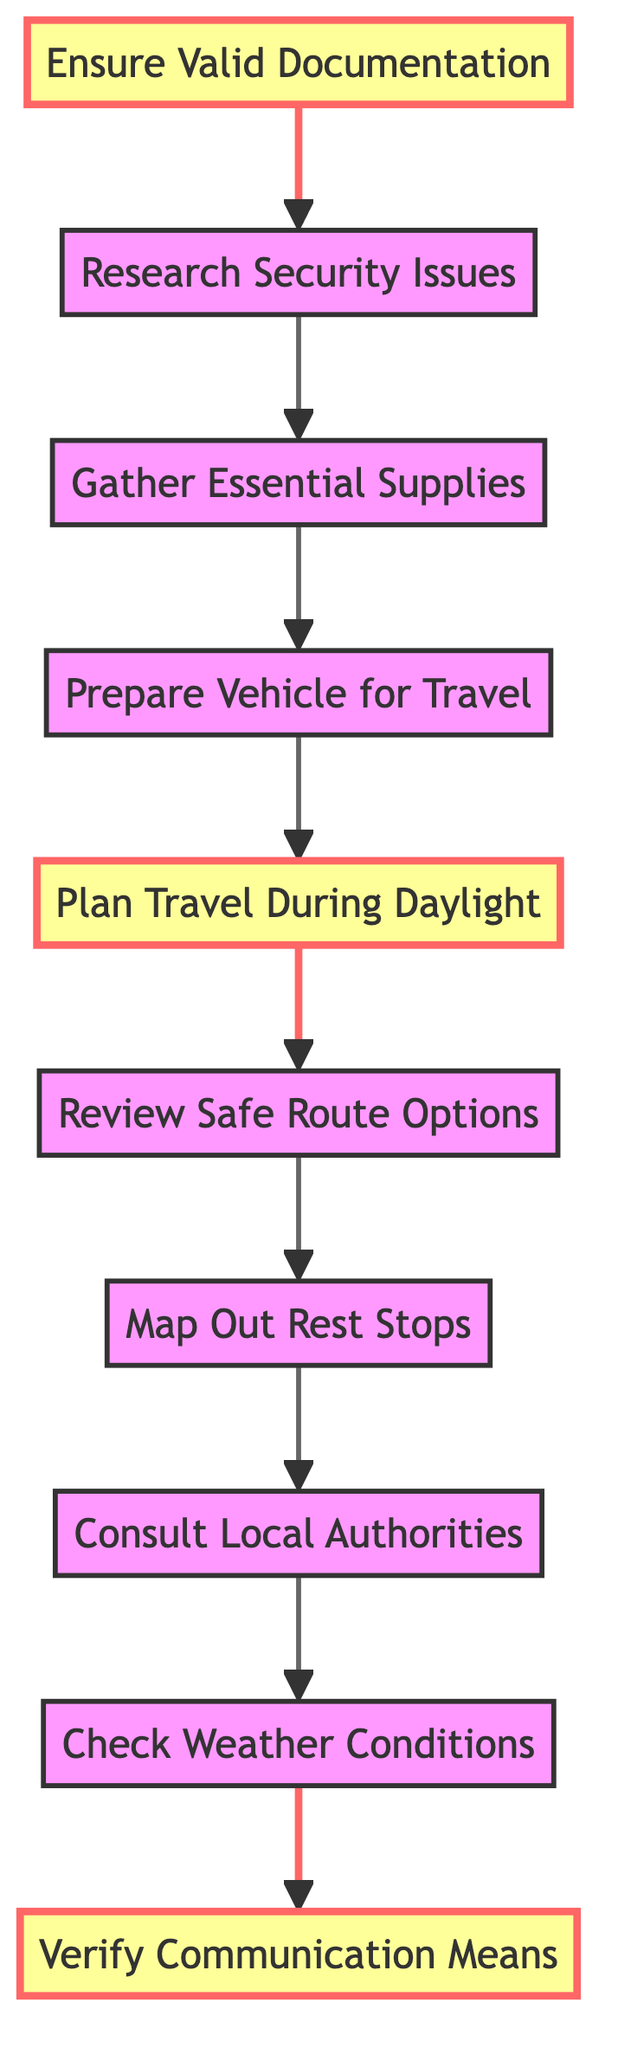What is the starting point of the flowchart? The flowchart starts at the node "Ensure Valid Documentation." This is the first action that needs to be taken, as indicated by the arrow pointing to the next node.
Answer: Ensure Valid Documentation How many nodes are present in the flowchart? The flowchart contains 10 nodes in total, each representing a different key action that needs to be taken to ensure safe road travel.
Answer: 10 What action follows "Plan Travel During Daylight"? The action that follows "Plan Travel During Daylight" is "Review Safe Route Options." This is the next step in the sequence, depicting the flow of tasks that follows planning the travel schedule.
Answer: Review Safe Route Options What is the last action in the flowchart? The last action in the flowchart is "Verify Communication Means." This represents the final check or measure taken to ensure safety before traveling.
Answer: Verify Communication Means Which action is indicated to be carried out before "Prepare Vehicle for Travel"? The action that needs to be completed before "Prepare Vehicle for Travel" is "Gather Essential Supplies." This follows the flow from one action to the next, showing the specific order of tasks.
Answer: Gather Essential Supplies What are the two highlighted actions in the flowchart? The two highlighted actions are "Ensure Valid Documentation" and "Plan Travel During Daylight." These actions are emphasized to indicate they are particularly important for the trip's safety planning.
Answer: Ensure Valid Documentation, Plan Travel During Daylight What information is needed before "Consult Local Authorities"? Before "Consult Local Authorities," the action "Map Out Rest Stops" must be completed. This indicates the necessary information that needs to be obtained prior to contacting local authorities.
Answer: Map Out Rest Stops If "Check Weather Conditions" is completed, what is the next step? After completing "Check Weather Conditions," the next step is "Verify Communication Means." This shows the flow sequence following the weather check.
Answer: Verify Communication Means How is "Review Safe Route Options" connected to "Prepare Vehicle for Travel"? "Review Safe Route Options" follows "Plan Travel During Daylight," and "Prepare Vehicle for Travel" follows "Gather Essential Supplies." Therefore, "Review Safe Route Options" influences the preparation status for the vehicle indirectly by making sure the route is safe before the vehicle is checked.
Answer: Indirectly through prior steps What critical action would you take first based on the diagram? Based on the diagram, the first critical action to take is "Ensure Valid Documentation," as it is the starting point and essential for legal travel.
Answer: Ensure Valid Documentation 